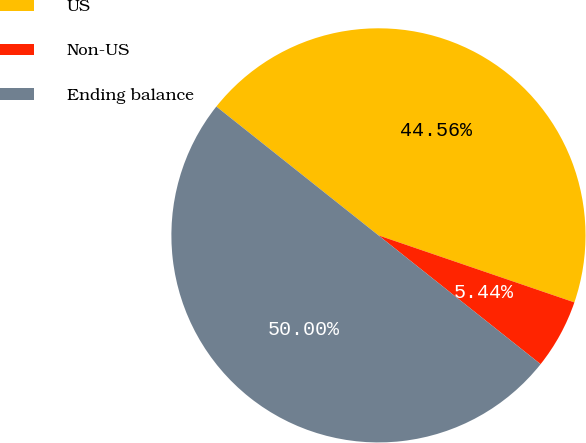Convert chart. <chart><loc_0><loc_0><loc_500><loc_500><pie_chart><fcel>US<fcel>Non-US<fcel>Ending balance<nl><fcel>44.56%<fcel>5.44%<fcel>50.0%<nl></chart> 